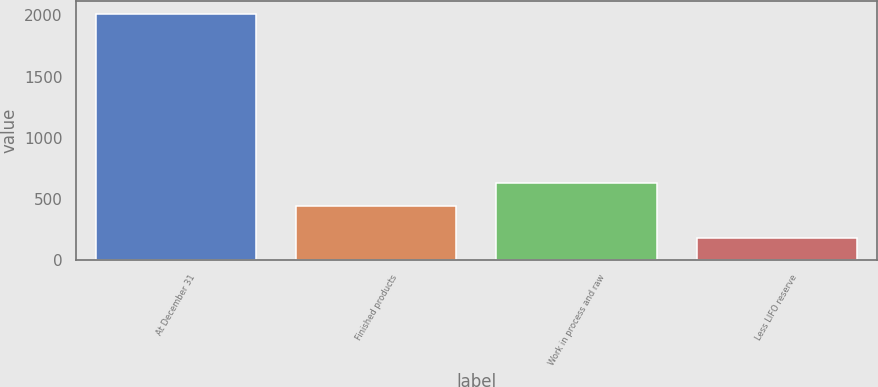Convert chart. <chart><loc_0><loc_0><loc_500><loc_500><bar_chart><fcel>At December 31<fcel>Finished products<fcel>Work in process and raw<fcel>Less LIFO reserve<nl><fcel>2015<fcel>443.6<fcel>627.5<fcel>176<nl></chart> 